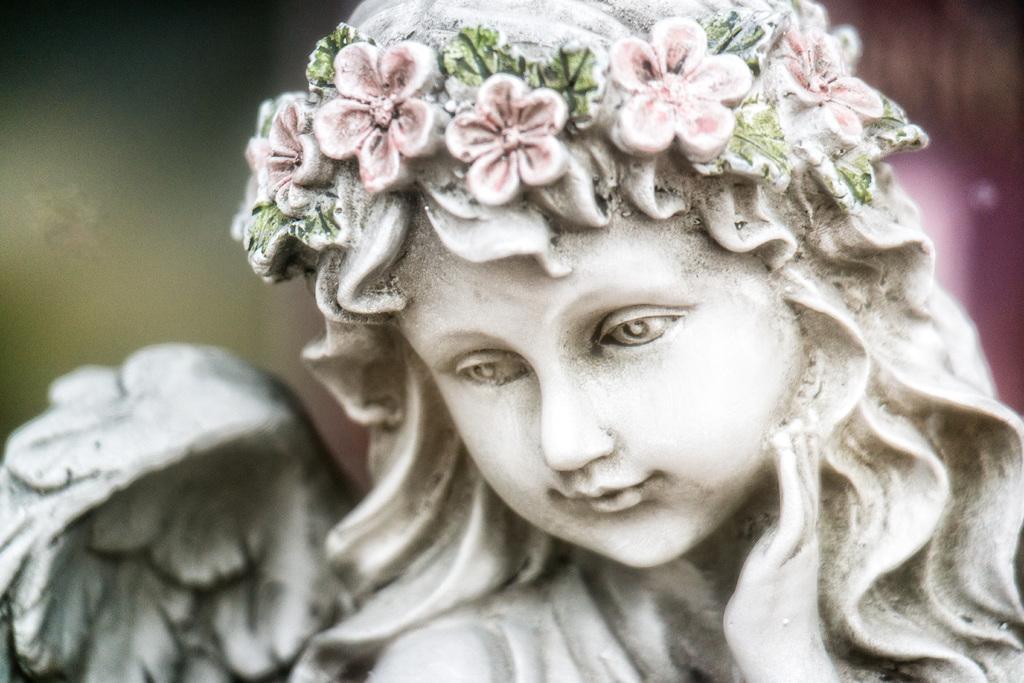Describe this image in one or two sentences. In this picture, we see a statue of a girl who is wearing a floral crown. In the background, it is in green and pink color and it is blurred in the background. 